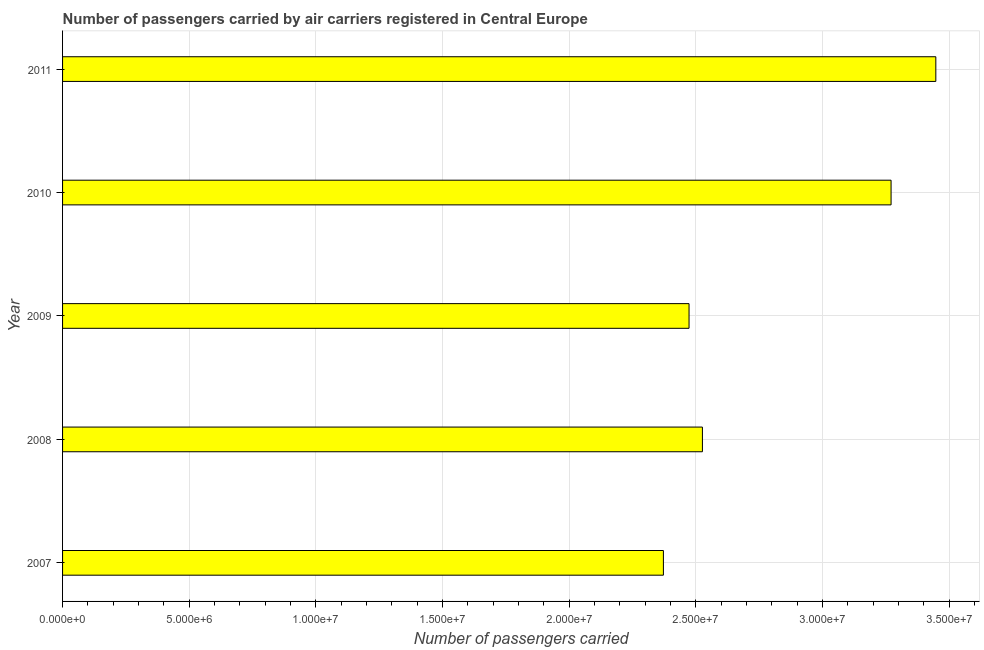Does the graph contain any zero values?
Your response must be concise. No. Does the graph contain grids?
Provide a succinct answer. Yes. What is the title of the graph?
Make the answer very short. Number of passengers carried by air carriers registered in Central Europe. What is the label or title of the X-axis?
Give a very brief answer. Number of passengers carried. What is the number of passengers carried in 2011?
Keep it short and to the point. 3.45e+07. Across all years, what is the maximum number of passengers carried?
Make the answer very short. 3.45e+07. Across all years, what is the minimum number of passengers carried?
Your answer should be compact. 2.37e+07. In which year was the number of passengers carried minimum?
Provide a short and direct response. 2007. What is the sum of the number of passengers carried?
Provide a succinct answer. 1.41e+08. What is the difference between the number of passengers carried in 2009 and 2011?
Your response must be concise. -9.74e+06. What is the average number of passengers carried per year?
Give a very brief answer. 2.82e+07. What is the median number of passengers carried?
Offer a very short reply. 2.53e+07. In how many years, is the number of passengers carried greater than 17000000 ?
Provide a succinct answer. 5. What is the ratio of the number of passengers carried in 2008 to that in 2011?
Offer a terse response. 0.73. Is the number of passengers carried in 2007 less than that in 2010?
Give a very brief answer. Yes. What is the difference between the highest and the second highest number of passengers carried?
Offer a terse response. 1.77e+06. Is the sum of the number of passengers carried in 2007 and 2008 greater than the maximum number of passengers carried across all years?
Offer a very short reply. Yes. What is the difference between the highest and the lowest number of passengers carried?
Offer a terse response. 1.08e+07. How many bars are there?
Your answer should be compact. 5. Are all the bars in the graph horizontal?
Your response must be concise. Yes. How many years are there in the graph?
Make the answer very short. 5. What is the Number of passengers carried of 2007?
Ensure brevity in your answer.  2.37e+07. What is the Number of passengers carried of 2008?
Ensure brevity in your answer.  2.53e+07. What is the Number of passengers carried in 2009?
Your response must be concise. 2.47e+07. What is the Number of passengers carried of 2010?
Provide a short and direct response. 3.27e+07. What is the Number of passengers carried in 2011?
Your answer should be very brief. 3.45e+07. What is the difference between the Number of passengers carried in 2007 and 2008?
Provide a short and direct response. -1.54e+06. What is the difference between the Number of passengers carried in 2007 and 2009?
Your response must be concise. -1.01e+06. What is the difference between the Number of passengers carried in 2007 and 2010?
Keep it short and to the point. -8.99e+06. What is the difference between the Number of passengers carried in 2007 and 2011?
Make the answer very short. -1.08e+07. What is the difference between the Number of passengers carried in 2008 and 2009?
Ensure brevity in your answer.  5.28e+05. What is the difference between the Number of passengers carried in 2008 and 2010?
Your answer should be compact. -7.45e+06. What is the difference between the Number of passengers carried in 2008 and 2011?
Give a very brief answer. -9.22e+06. What is the difference between the Number of passengers carried in 2009 and 2010?
Keep it short and to the point. -7.98e+06. What is the difference between the Number of passengers carried in 2009 and 2011?
Offer a very short reply. -9.74e+06. What is the difference between the Number of passengers carried in 2010 and 2011?
Your answer should be very brief. -1.77e+06. What is the ratio of the Number of passengers carried in 2007 to that in 2008?
Ensure brevity in your answer.  0.94. What is the ratio of the Number of passengers carried in 2007 to that in 2009?
Keep it short and to the point. 0.96. What is the ratio of the Number of passengers carried in 2007 to that in 2010?
Your answer should be compact. 0.72. What is the ratio of the Number of passengers carried in 2007 to that in 2011?
Provide a short and direct response. 0.69. What is the ratio of the Number of passengers carried in 2008 to that in 2010?
Your answer should be compact. 0.77. What is the ratio of the Number of passengers carried in 2008 to that in 2011?
Offer a terse response. 0.73. What is the ratio of the Number of passengers carried in 2009 to that in 2010?
Offer a terse response. 0.76. What is the ratio of the Number of passengers carried in 2009 to that in 2011?
Your answer should be very brief. 0.72. What is the ratio of the Number of passengers carried in 2010 to that in 2011?
Give a very brief answer. 0.95. 